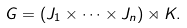Convert formula to latex. <formula><loc_0><loc_0><loc_500><loc_500>G = ( J _ { 1 } \times \cdots \times J _ { n } ) \rtimes K .</formula> 